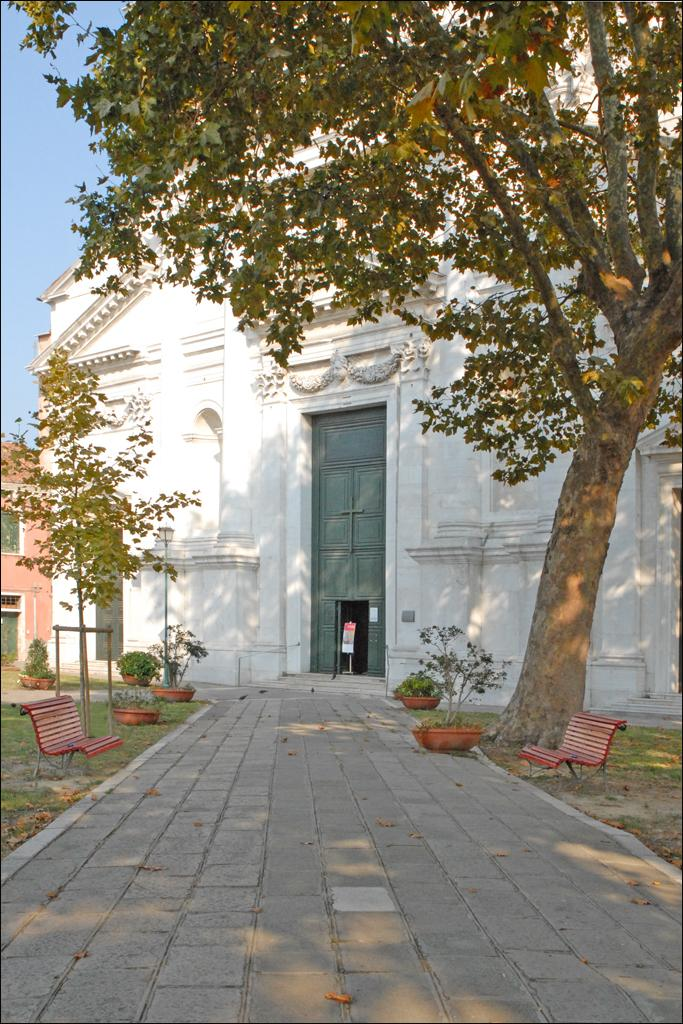What is the color of the building in the image? The building in the image is white. Where are the benches located in the image? The benches are located on the left and right sides of the image. What color are the benches in the image? The benches are orange in color. What type of vegetation is present in the image? There are trees in green color in the image. What color is the sky in the image? The sky is blue in the image. What type of powder is being used to clean the lace on the benches in the image? There is no powder or lace present in the image. The benches are orange and there are no cleaning activities depicted. 